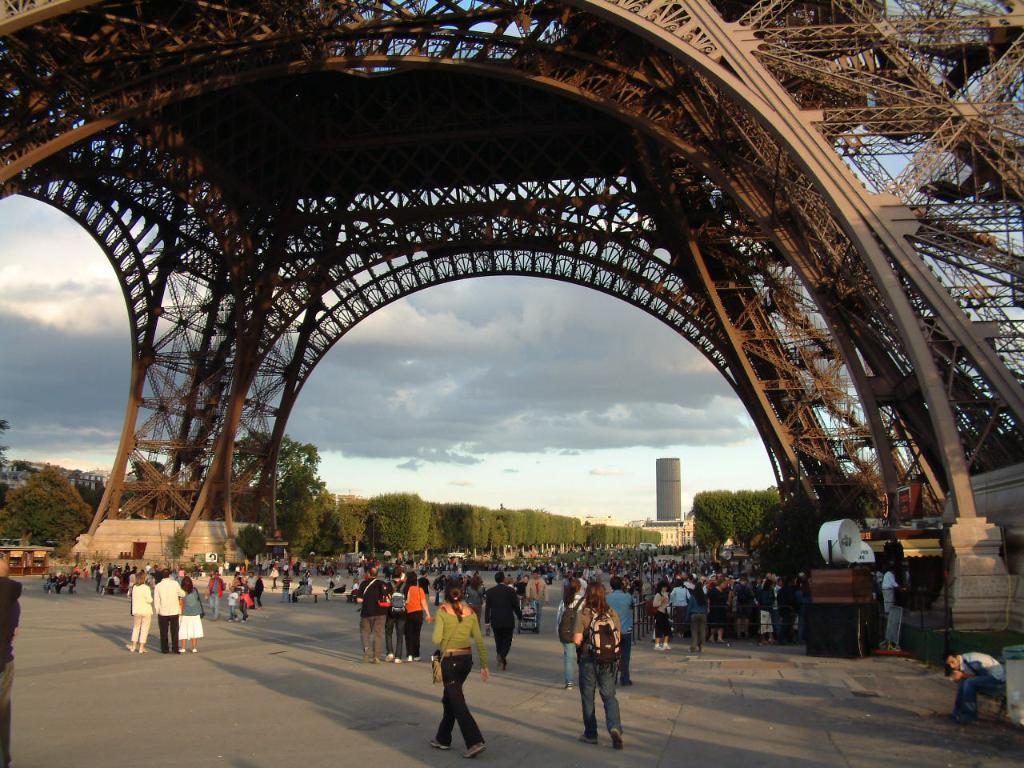How would you summarize this image in a sentence or two? In this picture we can see an eiffel tower. There are groups of people and some objects on the ground. Behind the people, there are trees, buildings and the cloudy sky. 